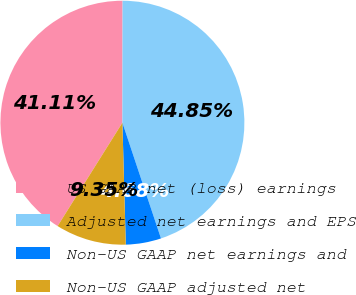Convert chart to OTSL. <chart><loc_0><loc_0><loc_500><loc_500><pie_chart><fcel>US GAAP net (loss) earnings<fcel>Adjusted net earnings and EPS<fcel>Non-US GAAP net earnings and<fcel>Non-US GAAP adjusted net<nl><fcel>41.11%<fcel>44.85%<fcel>4.68%<fcel>9.35%<nl></chart> 